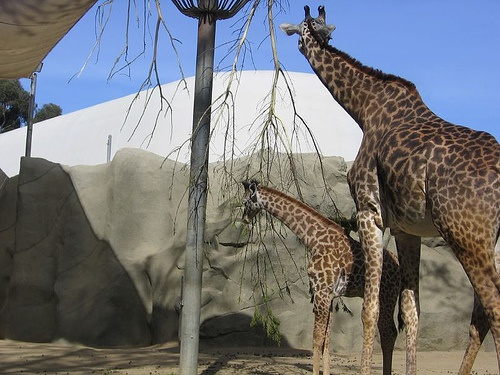Describe the objects in this image and their specific colors. I can see giraffe in black, gray, and maroon tones and giraffe in black, maroon, tan, and gray tones in this image. 